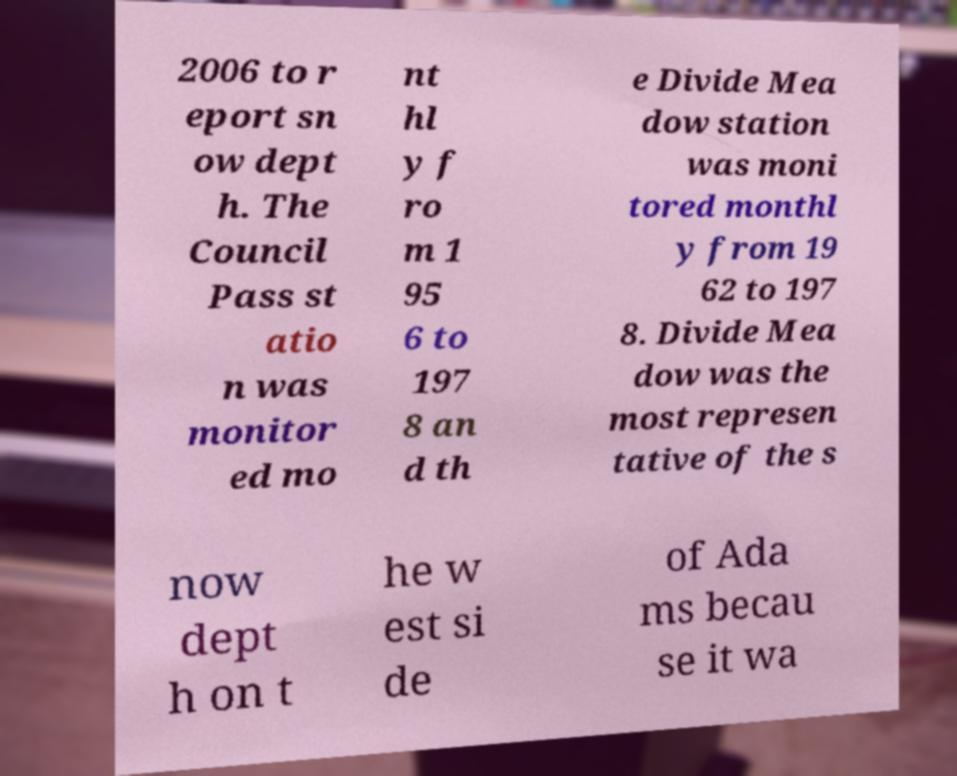Can you read and provide the text displayed in the image?This photo seems to have some interesting text. Can you extract and type it out for me? 2006 to r eport sn ow dept h. The Council Pass st atio n was monitor ed mo nt hl y f ro m 1 95 6 to 197 8 an d th e Divide Mea dow station was moni tored monthl y from 19 62 to 197 8. Divide Mea dow was the most represen tative of the s now dept h on t he w est si de of Ada ms becau se it wa 